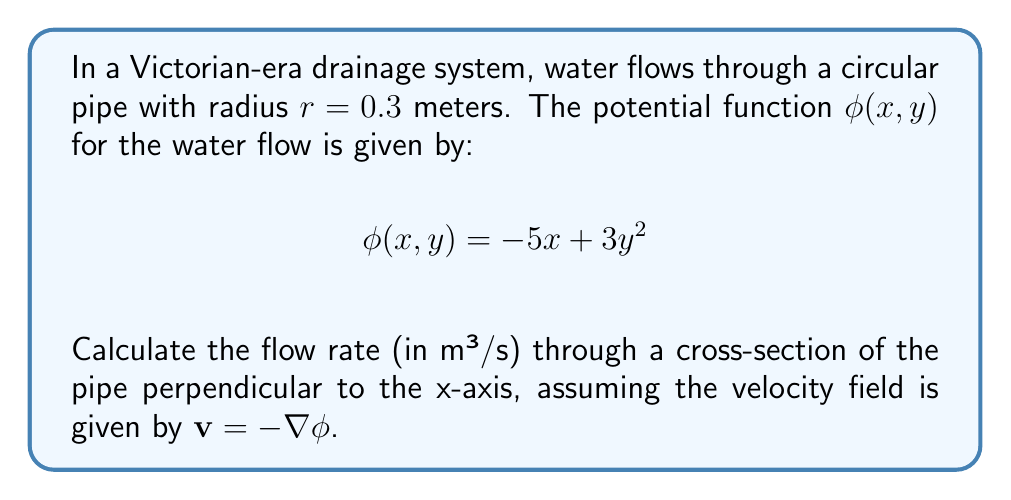Show me your answer to this math problem. Let's approach this step-by-step:

1) First, we need to find the velocity field $\mathbf{v}$. Given that $\mathbf{v} = -\nabla \phi$, we calculate:

   $$\mathbf{v} = -\left(\frac{\partial \phi}{\partial x}, \frac{\partial \phi}{\partial y}\right) = -((-5), 6y) = (5, -6y)$$

2) The flow rate Q is given by the surface integral of the velocity field over the cross-section:

   $$Q = \iint_S \mathbf{v} \cdot \mathbf{n} \, dS$$

   where $\mathbf{n}$ is the unit normal vector to the surface.

3) For a cross-section perpendicular to the x-axis, $\mathbf{n} = (1, 0)$, so we only need the x-component of $\mathbf{v}$, which is 5.

4) The cross-section is a circle with radius 0.3 m. We can parameterize this as:

   $$y = r \sin \theta, \quad z = r \cos \theta, \quad 0 \leq \theta \leq 2\pi$$

5) The flow rate is then:

   $$Q = \int_0^{2\pi} \int_0^r 5 \cdot r \, dr \, d\theta$$

6) Evaluating the integral:

   $$Q = 5 \int_0^{2\pi} \int_0^{0.3} r \, dr \, d\theta = 5 \cdot 2\pi \cdot \frac{r^2}{2}\bigg|_0^{0.3} = 5\pi \cdot (0.3)^2 = 0.45\pi$$

7) Therefore, the flow rate is $0.45\pi$ m³/s.
Answer: $0.45\pi$ m³/s 